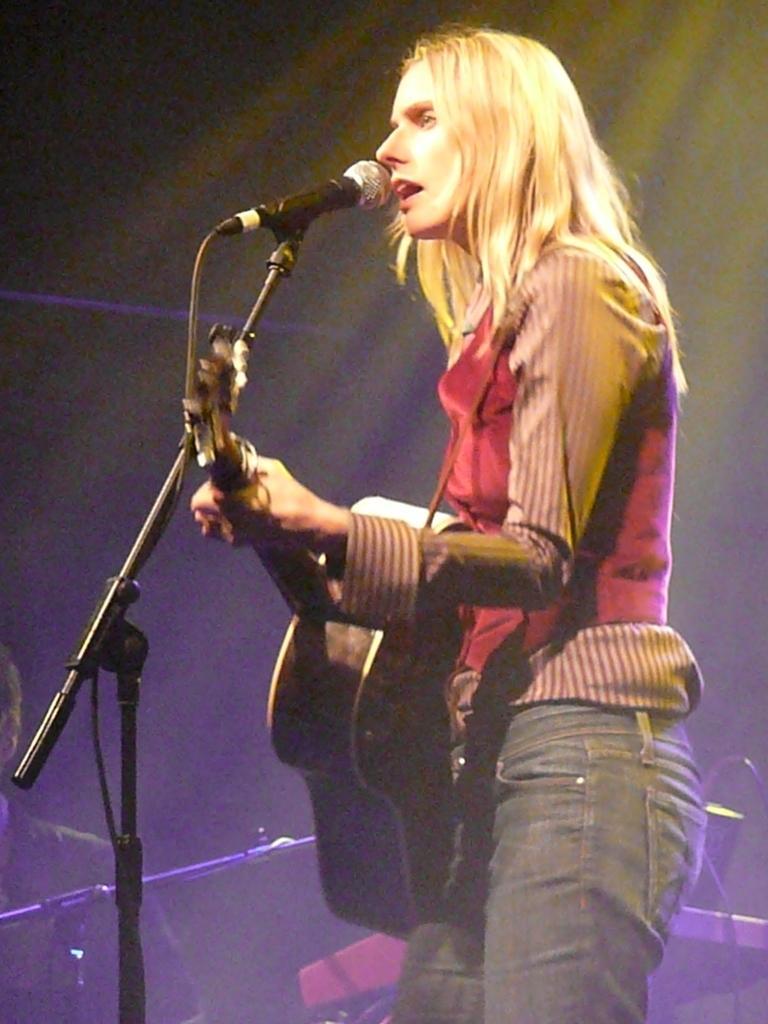Please provide a concise description of this image. This is a picture of a woman in red shirt holding a guitar and singing a song in front of the man there is a microphone with stand. Behind the woman there are some music systems. 